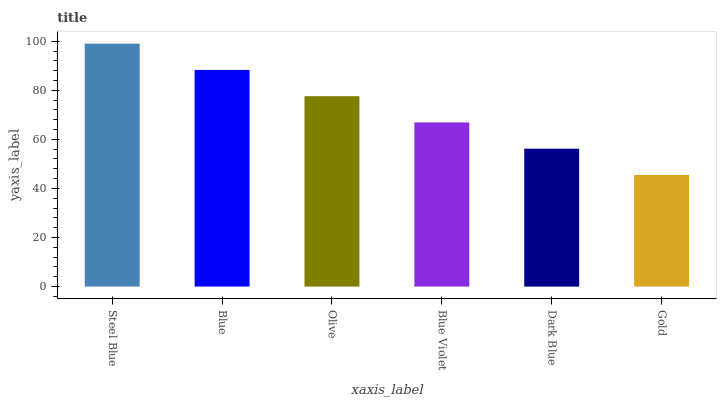Is Gold the minimum?
Answer yes or no. Yes. Is Steel Blue the maximum?
Answer yes or no. Yes. Is Blue the minimum?
Answer yes or no. No. Is Blue the maximum?
Answer yes or no. No. Is Steel Blue greater than Blue?
Answer yes or no. Yes. Is Blue less than Steel Blue?
Answer yes or no. Yes. Is Blue greater than Steel Blue?
Answer yes or no. No. Is Steel Blue less than Blue?
Answer yes or no. No. Is Olive the high median?
Answer yes or no. Yes. Is Blue Violet the low median?
Answer yes or no. Yes. Is Steel Blue the high median?
Answer yes or no. No. Is Steel Blue the low median?
Answer yes or no. No. 